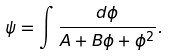Convert formula to latex. <formula><loc_0><loc_0><loc_500><loc_500>\psi = \int \frac { d \phi } { A + B \phi + \phi ^ { 2 } } .</formula> 